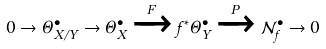Convert formula to latex. <formula><loc_0><loc_0><loc_500><loc_500>0 \to \Theta _ { X / Y } ^ { \bullet } \to \Theta _ { X } ^ { \bullet } \xrightarrow { F } f ^ { * } \Theta _ { Y } ^ { \bullet } \xrightarrow { P } \mathcal { N } _ { f } ^ { \bullet } \to 0</formula> 